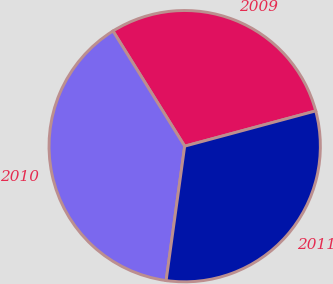Convert chart. <chart><loc_0><loc_0><loc_500><loc_500><pie_chart><fcel>2009<fcel>2010<fcel>2011<nl><fcel>29.68%<fcel>38.95%<fcel>31.37%<nl></chart> 